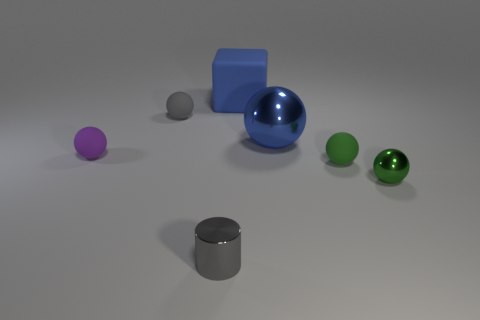Subtract all brown cubes. How many green spheres are left? 2 Subtract all small purple matte spheres. How many spheres are left? 4 Subtract all green balls. How many balls are left? 3 Subtract 1 balls. How many balls are left? 4 Add 2 big blue rubber things. How many objects exist? 9 Subtract all purple spheres. Subtract all green cubes. How many spheres are left? 4 Add 6 small purple matte things. How many small purple matte things exist? 7 Subtract 0 yellow cylinders. How many objects are left? 7 Subtract all spheres. How many objects are left? 2 Subtract all big matte objects. Subtract all tiny yellow spheres. How many objects are left? 6 